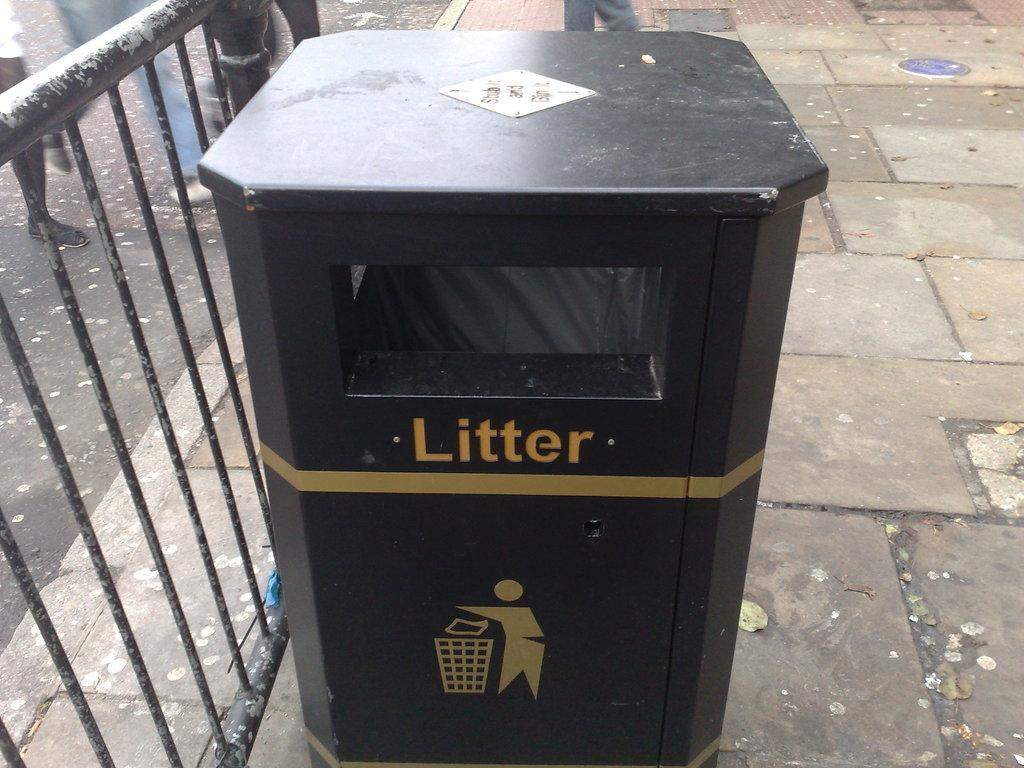<image>
Describe the image concisely. The trash can tells you that is where you should throw away litter. 